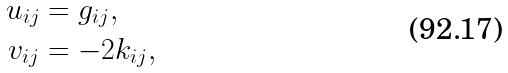Convert formula to latex. <formula><loc_0><loc_0><loc_500><loc_500>u _ { i j } & = g _ { i j } , \\ v _ { i j } & = - 2 k _ { i j } ,</formula> 